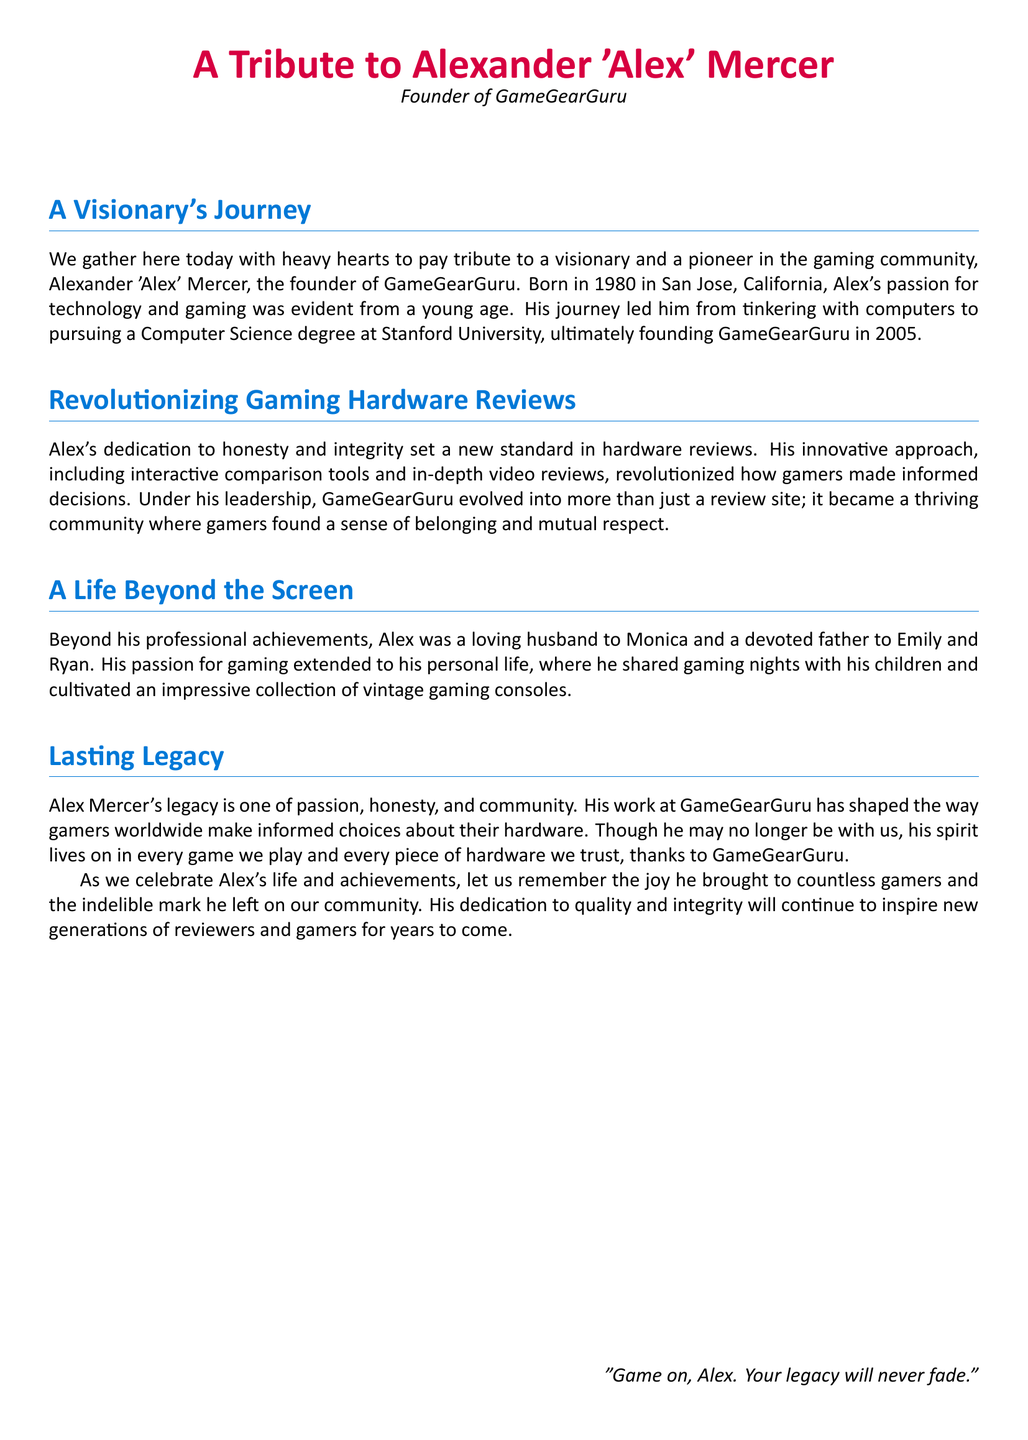What is the full name of the founder? The document states his full name as Alexander 'Alex' Mercer.
Answer: Alexander 'Alex' Mercer What is the name of the gaming hardware review site founded by Alex? The document mentions the site as GameGearGuru.
Answer: GameGearGuru In what year was GameGearGuru founded? The document indicates that the site was founded in 2005.
Answer: 2005 Where was Alex Mercer born? The document specifies that he was born in San Jose, California.
Answer: San Jose, California Who are Alex Mercer’s children? The document names his children as Emily and Ryan.
Answer: Emily and Ryan What degree did Alex pursue at Stanford University? The text states he pursued a Computer Science degree.
Answer: Computer Science What innovative approach did Alex introduce in hardware reviews? The document mentions interactive comparison tools and in-depth video reviews as his innovations.
Answer: Interactive comparison tools and in-depth video reviews What quality did Alex prioritize in his reviews? The document emphasizes his dedication to honesty and integrity.
Answer: Honesty and integrity How does the document describe GameGearGuru under Alex’s leadership? It describes GameGearGuru as a thriving community where gamers found belonging.
Answer: A thriving community What closing sentiment is expressed in the document? The document ends with the phrase “Game on, Alex. Your legacy will never fade.”
Answer: Game on, Alex. Your legacy will never fade 